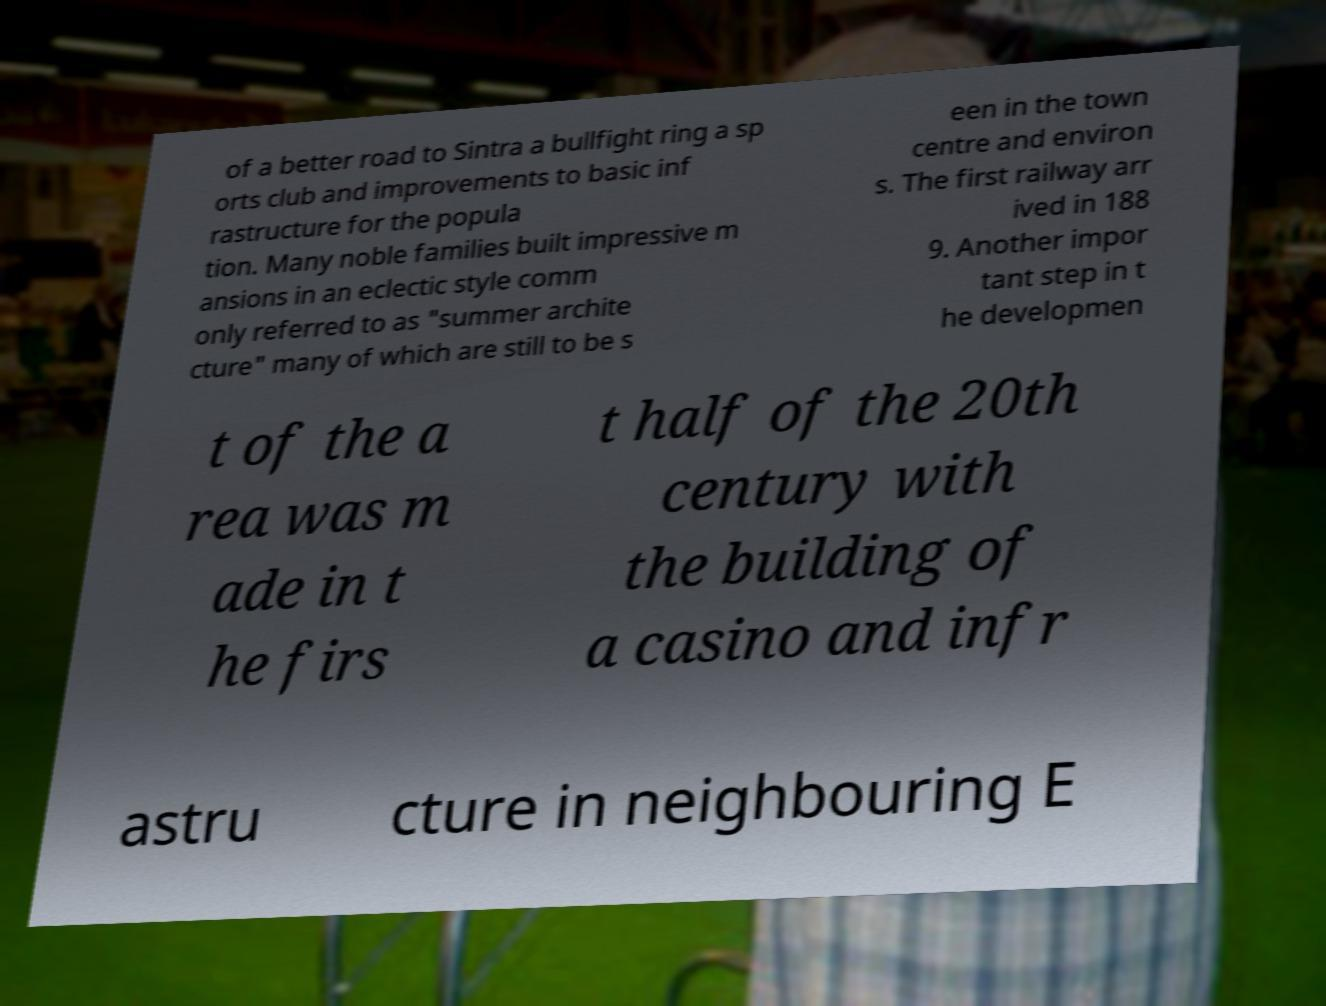What messages or text are displayed in this image? I need them in a readable, typed format. of a better road to Sintra a bullfight ring a sp orts club and improvements to basic inf rastructure for the popula tion. Many noble families built impressive m ansions in an eclectic style comm only referred to as "summer archite cture" many of which are still to be s een in the town centre and environ s. The first railway arr ived in 188 9. Another impor tant step in t he developmen t of the a rea was m ade in t he firs t half of the 20th century with the building of a casino and infr astru cture in neighbouring E 